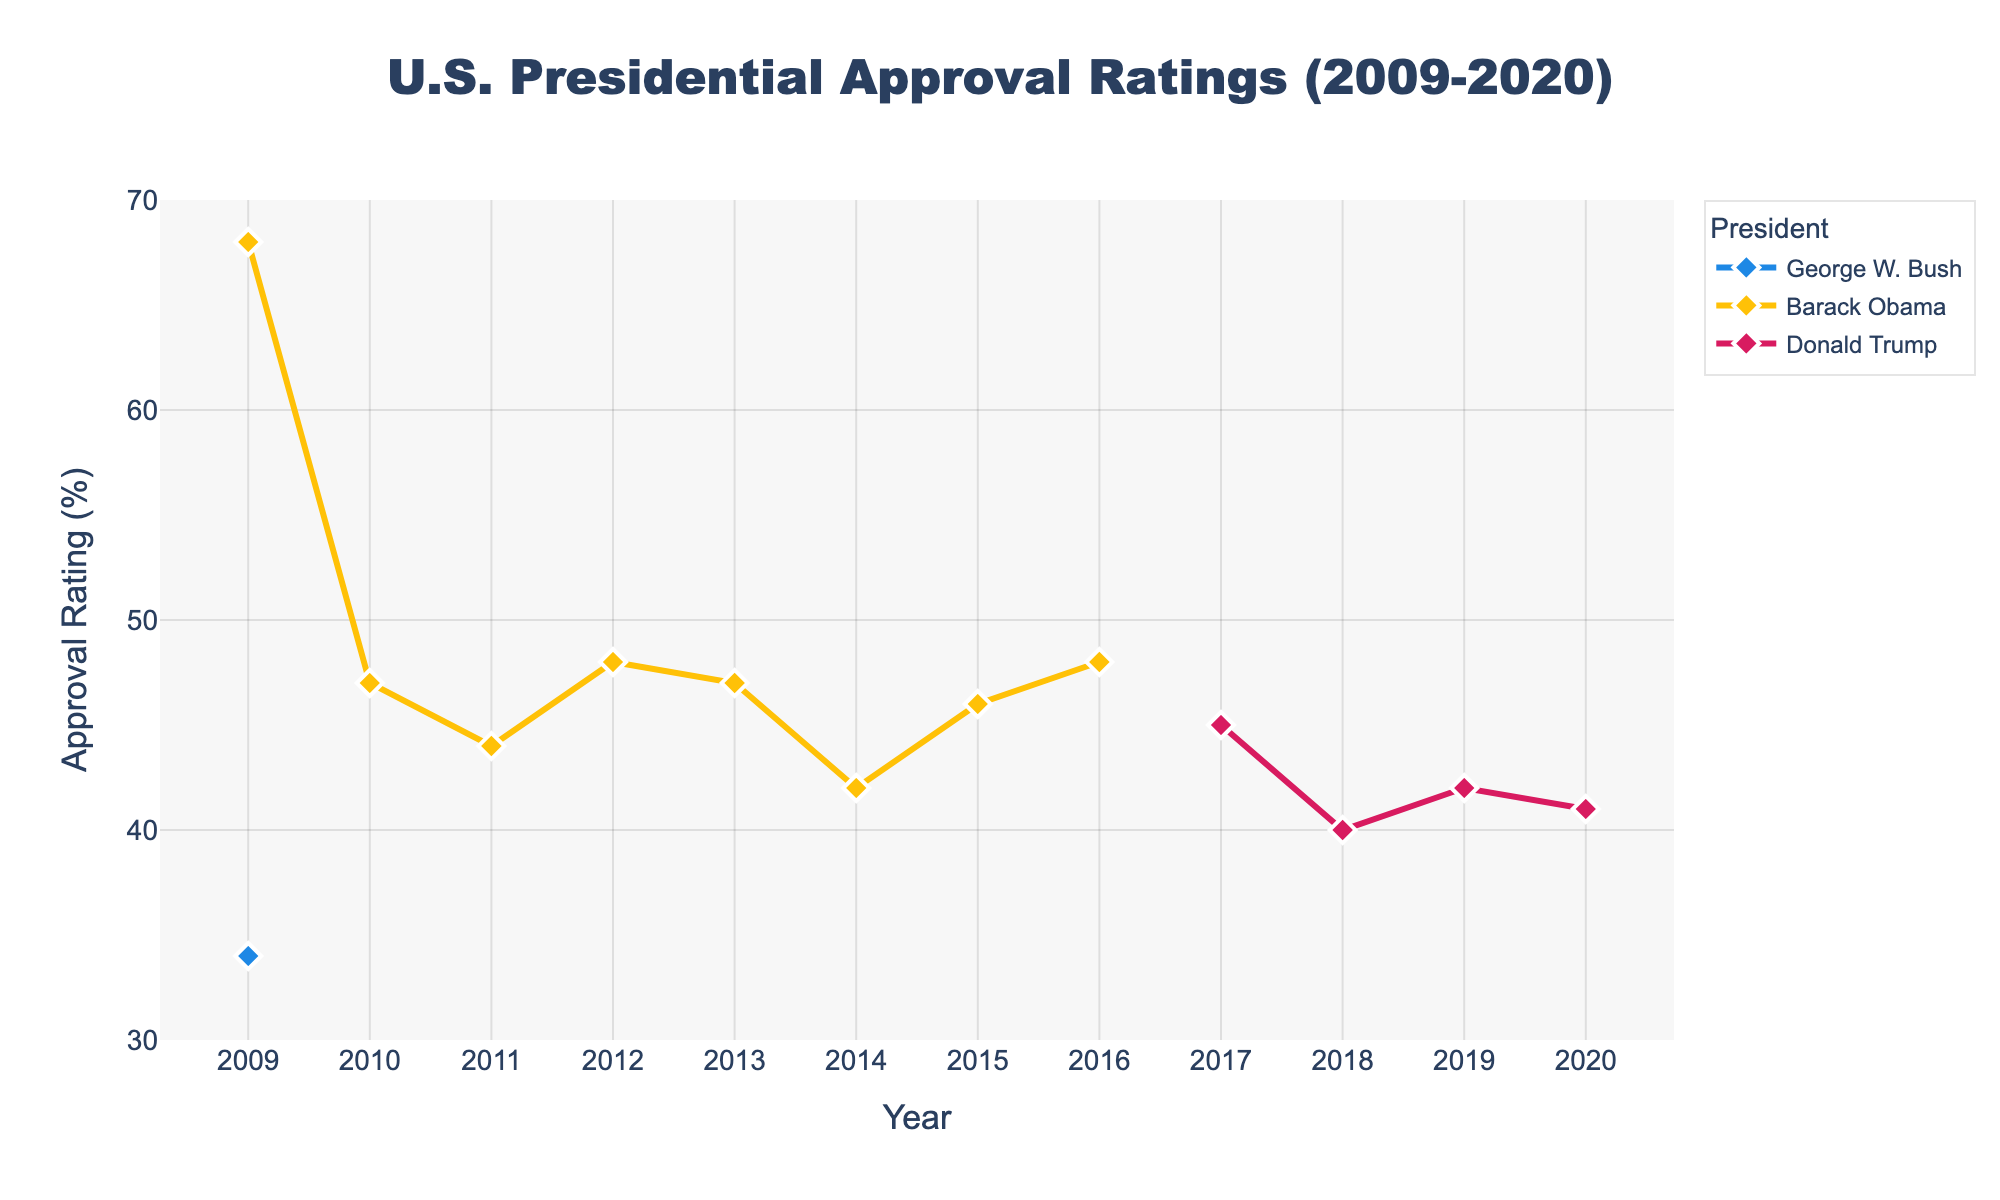What is the average approval rating of Barack Obama during his term? To calculate the average approval rating of Barack Obama, sum all the yearly approval ratings and divide by the number of years with available data: (68 + 47 + 44 + 48 + 47 + 42 + 46 + 48) / 8.
Answer: 48 How did Donald Trump’s approval rating change from 2017 to 2020? First, find the approval rating for Trump in 2017 (45) and in 2020 (41). Then, subtract the 2020 value from the 2017 value: 45 - 41.
Answer: It decreased by 4 points Which president had the highest approval rating at any point in the data? Observe the highest point among all the lines in the plot. Barack Obama's approval rating in 2009 is the highest at 68.
Answer: Barack Obama Between which years did George W. Bush experience an increase in his approval rating? Check the data points for George W. Bush. His approval rating increased from 2011 (44) to 2012 (48).
Answer: 2011 to 2012 In which year did George H. W. Bush end his term according to the plot? George H. W. Bush's data ends before 2009. Hence, he ended his term before the plot timeline begins.
Answer: Before 2009 Whose approval rating showed the most stability during their term? Observe the trendlines of the presidents. George W. Bush’s line appears relatively flat with minor fluctuations between 2009-2016.
Answer: George W. Bush In 2010, which president had the highest approval rating? Identify the data point for 2010. Only Barack Obama's rating is available for 2010, which is 47.
Answer: Barack Obama What is the range of Donald Trump's approval ratings throughout his term? Determine the highest (45 in 2017) and the lowest (40 in 2018) approval ratings for Trump, then calculate the difference (45 - 40).
Answer: 5 points Calculate the total approval rating of Barack Obama and George W. Bush combined in 2014. Add Barack Obama's 2014 approval rating (42) with George W. Bush's 2014 approval rating (42).
Answer: 84 Whose approval rating fell the most from one year to the next? Compare the year-on-year changes for each president. Donald Trump had the largest drop between 2017 (45) and 2018 (40): 45 - 40 = 5.
Answer: Donald Trump 